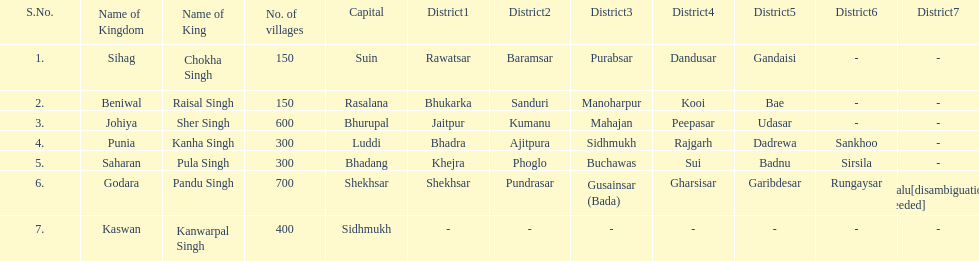He was the king of the sihag kingdom. Chokha Singh. 